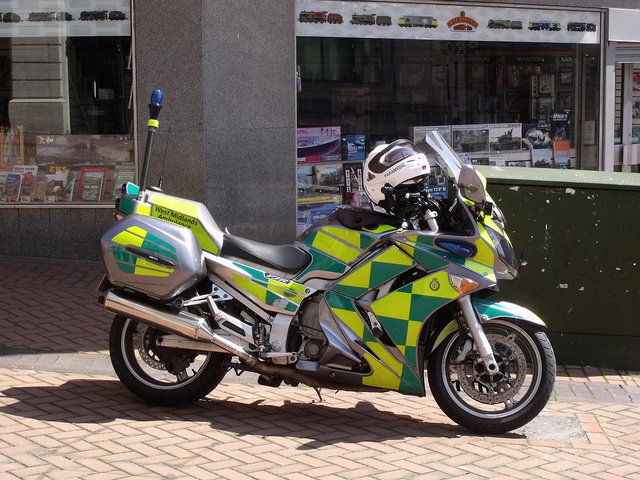Describe the objects in this image and their specific colors. I can see motorcycle in gray, black, darkgray, and olive tones, book in gray, black, and maroon tones, book in gray and black tones, train in gray, black, maroon, and darkgray tones, and book in gray, black, and purple tones in this image. 